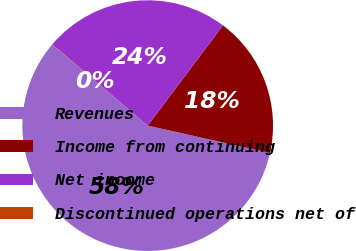Convert chart to OTSL. <chart><loc_0><loc_0><loc_500><loc_500><pie_chart><fcel>Revenues<fcel>Income from continuing<fcel>Net income<fcel>Discontinued operations net of<nl><fcel>57.68%<fcel>18.26%<fcel>24.02%<fcel>0.04%<nl></chart> 